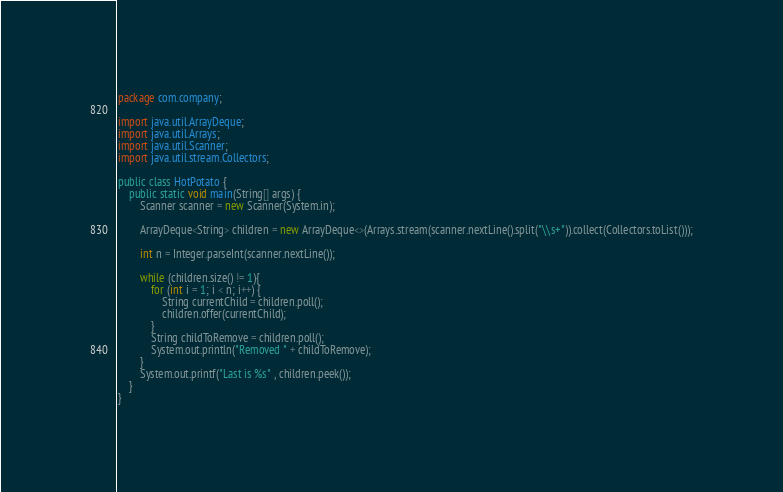<code> <loc_0><loc_0><loc_500><loc_500><_Java_>package com.company;

import java.util.ArrayDeque;
import java.util.Arrays;
import java.util.Scanner;
import java.util.stream.Collectors;

public class HotPotato {
    public static void main(String[] args) {
        Scanner scanner = new Scanner(System.in);

        ArrayDeque<String> children = new ArrayDeque<>(Arrays.stream(scanner.nextLine().split("\\s+")).collect(Collectors.toList()));

        int n = Integer.parseInt(scanner.nextLine());

        while (children.size() != 1){
            for (int i = 1; i < n; i++) {
                String currentChild = children.poll();
                children.offer(currentChild);
            }
            String childToRemove = children.poll();
            System.out.println("Removed " + childToRemove);
        }
        System.out.printf("Last is %s" , children.peek());
    }
}
</code> 